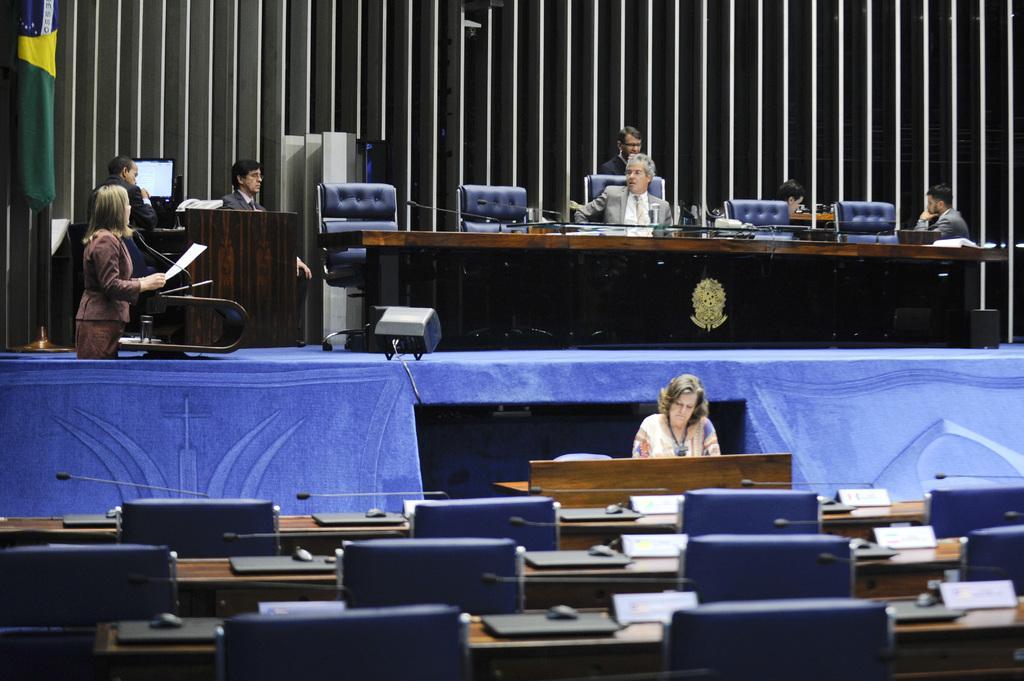Please provide a concise description of this image. On the left a woman is standing and speaking in the microphone in the middle a man is sitting in the chair. 